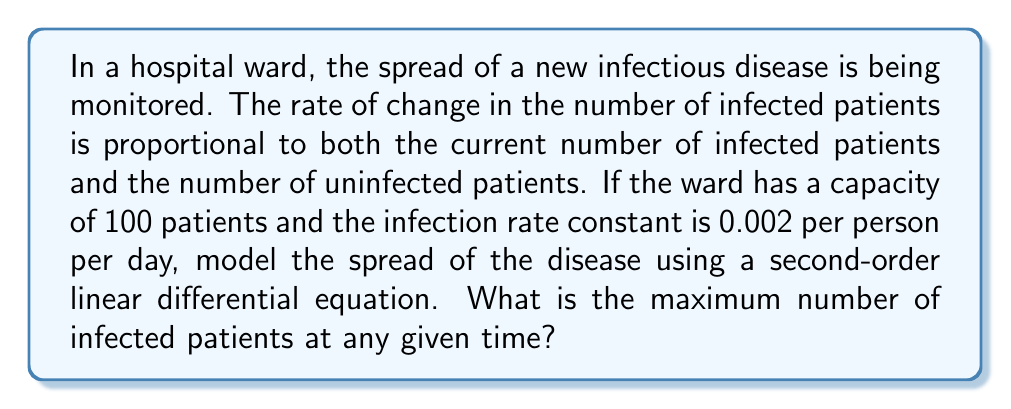Can you answer this question? Let's approach this step-by-step:

1) Let $y(t)$ be the number of infected patients at time $t$.

2) The rate of change in infected patients is given by:

   $$\frac{dy}{dt} = ky(100-y)$$

   where $k = 0.002$ is the infection rate constant, and $(100-y)$ represents the number of uninfected patients.

3) To find the maximum number of infected patients, we need to find when $\frac{dy}{dt} = 0$:

   $$0 = 0.002y(100-y)$$

4) Solving this equation:
   
   $y = 0$ or $y = 100$

5) $y = 0$ represents the initial condition (no infected patients), while $y = 100$ represents all patients infected. However, the question asks for the maximum number of infected patients at any given time.

6) To confirm this is indeed a maximum, we can take the second derivative:

   $$\frac{d^2y}{dt^2} = 0.002(100-y)\frac{dy}{dt} - 0.002y\frac{dy}{dt}$$
   $$= 0.002(100-2y)\frac{dy}{dt}$$

7) At $y = 50$, $\frac{d^2y}{dt^2} < 0$, confirming it's a maximum.

8) Therefore, the maximum number of infected patients occurs when half the ward is infected, i.e., when $y = 50$.
Answer: The maximum number of infected patients at any given time is 50. 